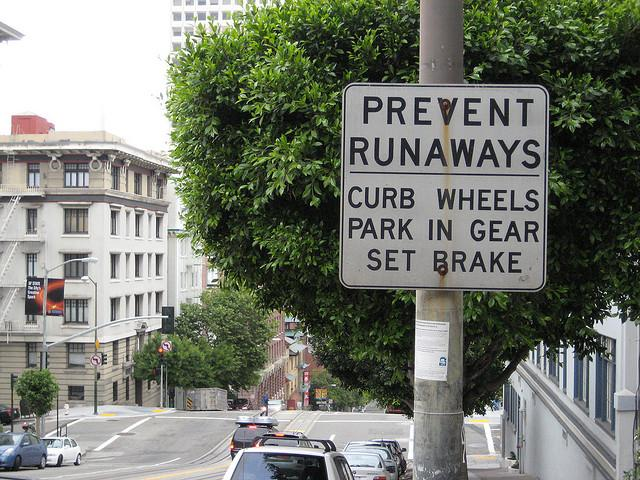What type vehicle does this sign refer to? Please explain your reasoning. large truck. This is because a big vehicle will roll easy on a hill 